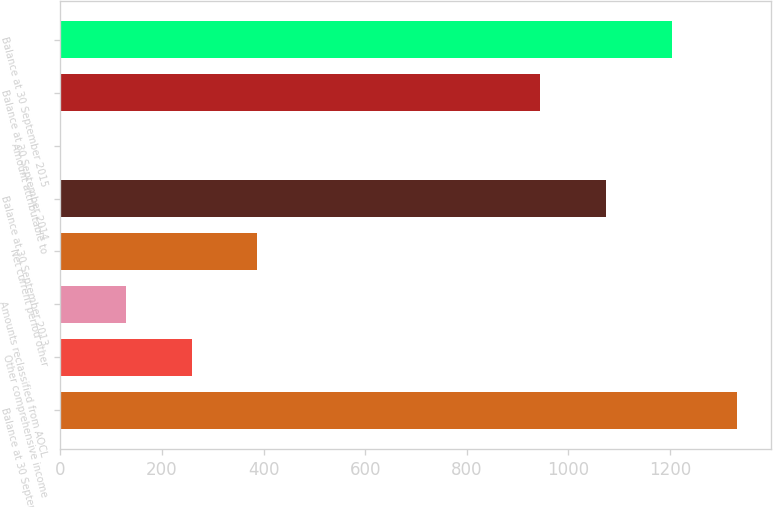Convert chart to OTSL. <chart><loc_0><loc_0><loc_500><loc_500><bar_chart><fcel>Balance at 30 September 2012<fcel>Other comprehensive income<fcel>Amounts reclassified from AOCL<fcel>Net current period other<fcel>Balance at 30 September 2013<fcel>Amount attributable to<fcel>Balance at 30 September 2014<fcel>Balance at 30 September 2015<nl><fcel>1331.97<fcel>258.38<fcel>129.29<fcel>387.47<fcel>1073.79<fcel>0.2<fcel>944.7<fcel>1202.88<nl></chart> 